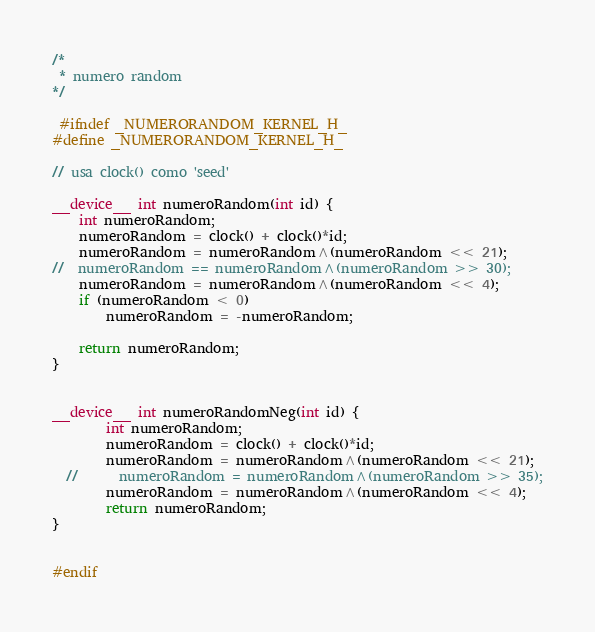<code> <loc_0><loc_0><loc_500><loc_500><_Cuda_>/*
 * numero random
*/

 #ifndef _NUMERORANDOM_KERNEL_H_
#define _NUMERORANDOM_KERNEL_H_

// usa clock() como 'seed'

__device__ int numeroRandom(int id) {
	int numeroRandom;
	numeroRandom = clock() + clock()*id;
	numeroRandom = numeroRandom^(numeroRandom << 21);
//	numeroRandom == numeroRandom^(numeroRandom >> 30);
	numeroRandom = numeroRandom^(numeroRandom << 4);
	if (numeroRandom < 0)
		numeroRandom = -numeroRandom;

	return numeroRandom;
}


__device__ int numeroRandomNeg(int id) {
        int numeroRandom;
        numeroRandom = clock() + clock()*id;
        numeroRandom = numeroRandom^(numeroRandom << 21);
  //      numeroRandom = numeroRandom^(numeroRandom >> 35);
        numeroRandom = numeroRandom^(numeroRandom << 4);
        return numeroRandom;
}


#endif
</code> 